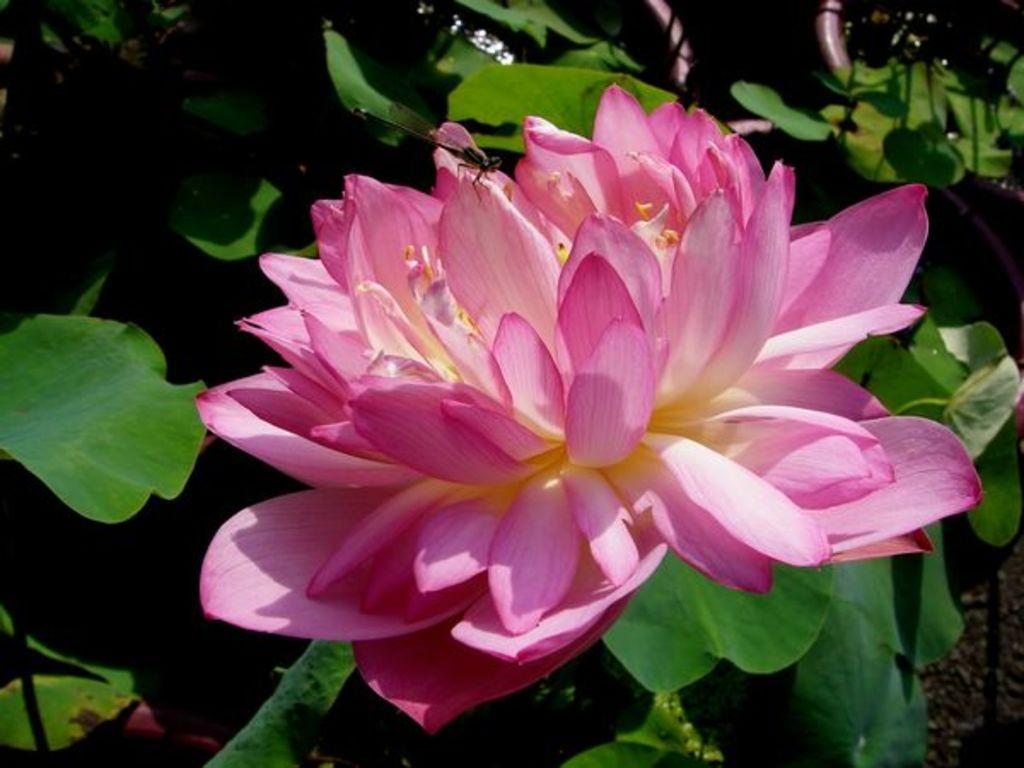What type of flower is in the image? There is a pink lotus flower in the image. Where is the lotus flower located? The lotus flower is on a plant. What other parts of the plant can be seen in the image? Leaves are visible in the image. What type of lunchroom equipment can be seen in the image? There is no lunchroom equipment present in the image; it features a pink lotus flower on a plant with visible leaves. 